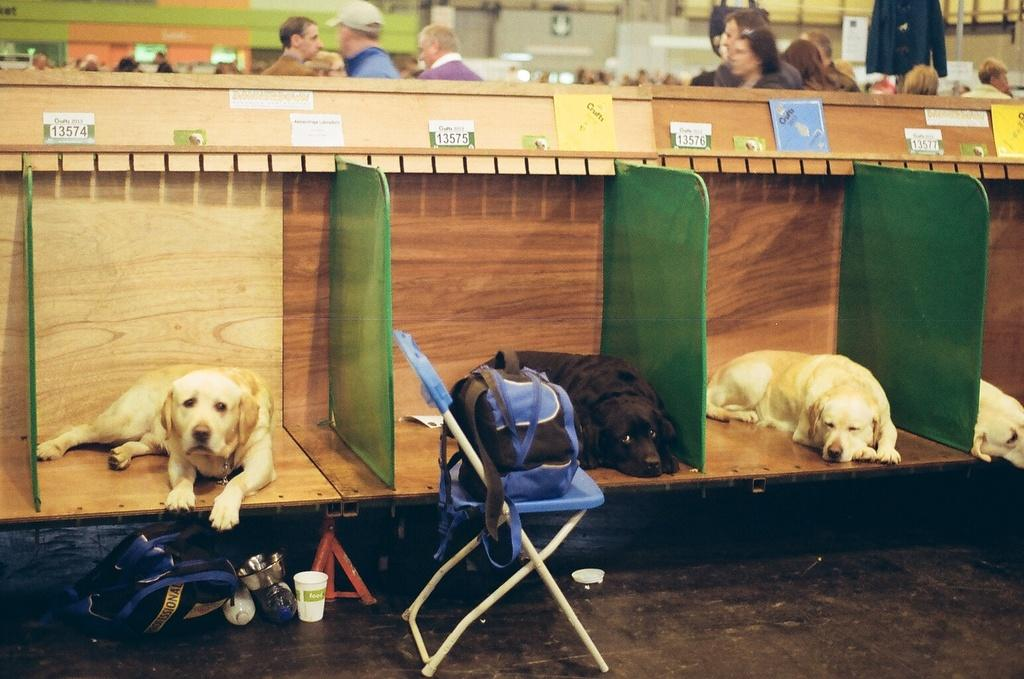How many dogs are present in the image? There are four dogs in the image. What are the dogs doing in the image? The dogs are lying on desks. What other objects can be seen in the image besides the dogs? There are bags and a chair visible in the image. What can be seen in the background of the image? There are people, a wall, and boards in the background of the image. What type of cushion is being used by the dogs to mark their territory in the image? There is no cushion present in the image, nor is there any indication of the dogs marking their territory. 